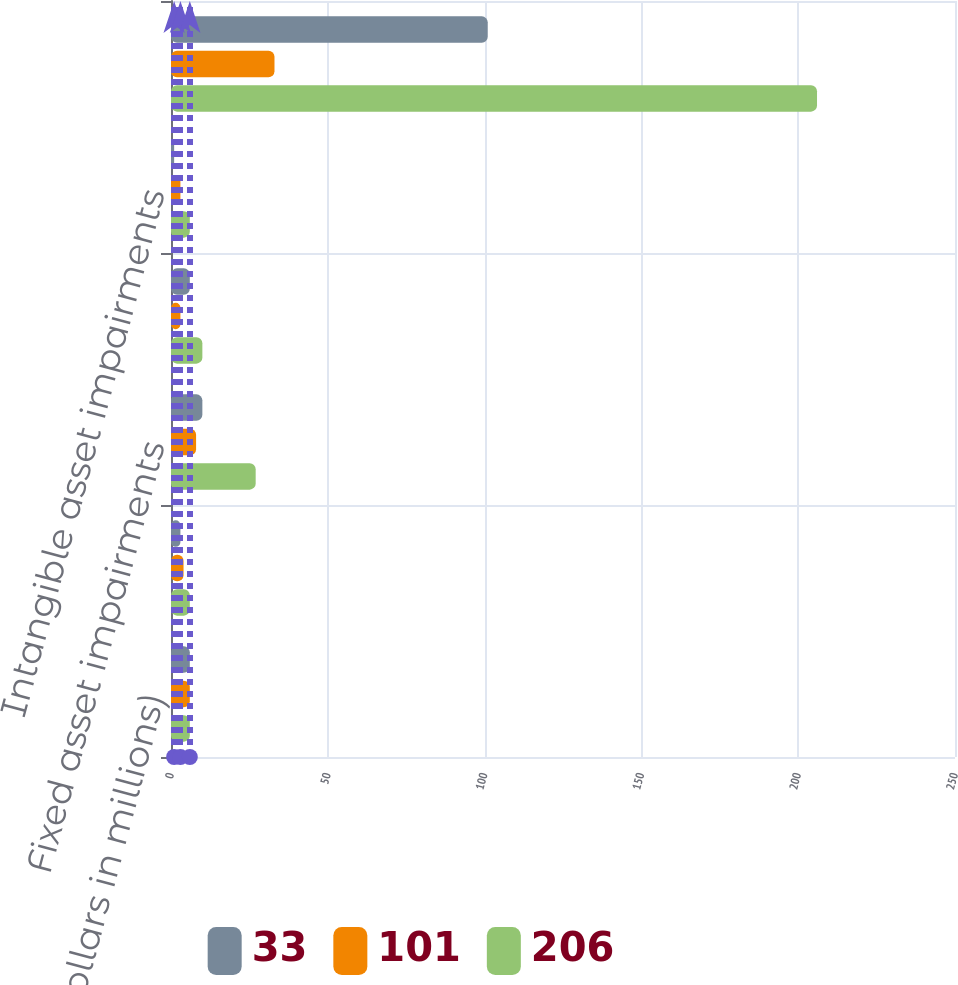<chart> <loc_0><loc_0><loc_500><loc_500><stacked_bar_chart><ecel><fcel>(Dollars in millions)<fcel>Site closure and restructuring<fcel>Fixed asset impairments<fcel>Severance charges<fcel>Intangible asset impairments<fcel>Total Eastman Chemical Company<nl><fcel>33<fcel>6<fcel>3<fcel>10<fcel>6<fcel>1<fcel>101<nl><fcel>101<fcel>6<fcel>4<fcel>8<fcel>3<fcel>3<fcel>33<nl><fcel>206<fcel>6<fcel>6<fcel>27<fcel>10<fcel>6<fcel>206<nl></chart> 